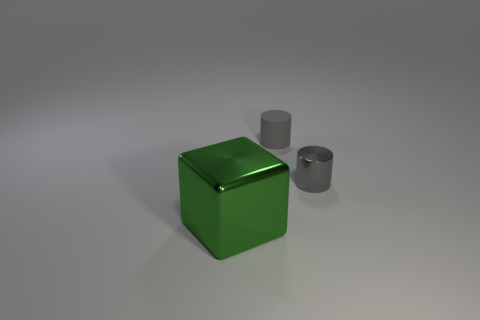Are there any other things that have the same color as the cube?
Provide a succinct answer. No. Do the tiny rubber thing and the tiny metallic thing have the same color?
Provide a short and direct response. Yes. There is another small gray object that is the same shape as the tiny shiny thing; what is it made of?
Keep it short and to the point. Rubber. Is the shape of the object on the right side of the tiny gray rubber object the same as the small thing behind the small shiny cylinder?
Make the answer very short. Yes. Is there a gray thing that has the same material as the green block?
Provide a succinct answer. Yes. Are the tiny gray cylinder right of the rubber cylinder and the big block made of the same material?
Ensure brevity in your answer.  Yes. Are there more large green objects that are behind the big green shiny thing than tiny gray objects on the left side of the gray matte object?
Keep it short and to the point. No. There is a rubber cylinder that is the same size as the gray shiny object; what color is it?
Give a very brief answer. Gray. Are there any other small cylinders of the same color as the shiny cylinder?
Your answer should be very brief. Yes. There is a cylinder that is left of the metallic cylinder; is its color the same as the metallic object that is on the right side of the green metallic block?
Make the answer very short. Yes. 